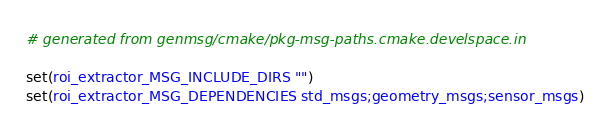<code> <loc_0><loc_0><loc_500><loc_500><_CMake_># generated from genmsg/cmake/pkg-msg-paths.cmake.develspace.in

set(roi_extractor_MSG_INCLUDE_DIRS "")
set(roi_extractor_MSG_DEPENDENCIES std_msgs;geometry_msgs;sensor_msgs)
</code> 